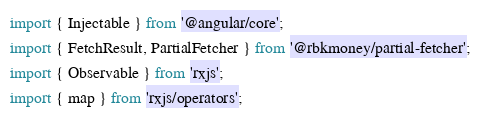Convert code to text. <code><loc_0><loc_0><loc_500><loc_500><_TypeScript_>import { Injectable } from '@angular/core';
import { FetchResult, PartialFetcher } from '@rbkmoney/partial-fetcher';
import { Observable } from 'rxjs';
import { map } from 'rxjs/operators';
</code> 